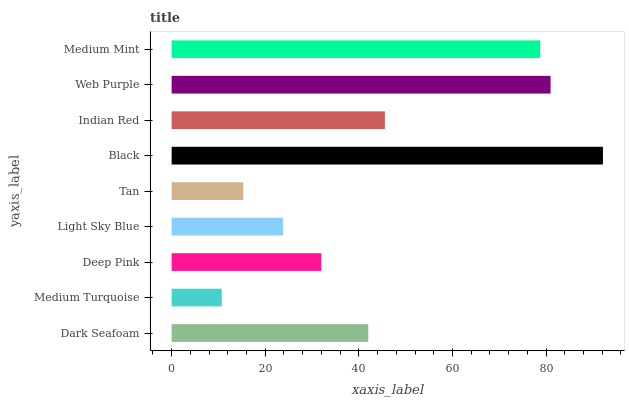Is Medium Turquoise the minimum?
Answer yes or no. Yes. Is Black the maximum?
Answer yes or no. Yes. Is Deep Pink the minimum?
Answer yes or no. No. Is Deep Pink the maximum?
Answer yes or no. No. Is Deep Pink greater than Medium Turquoise?
Answer yes or no. Yes. Is Medium Turquoise less than Deep Pink?
Answer yes or no. Yes. Is Medium Turquoise greater than Deep Pink?
Answer yes or no. No. Is Deep Pink less than Medium Turquoise?
Answer yes or no. No. Is Dark Seafoam the high median?
Answer yes or no. Yes. Is Dark Seafoam the low median?
Answer yes or no. Yes. Is Medium Mint the high median?
Answer yes or no. No. Is Black the low median?
Answer yes or no. No. 